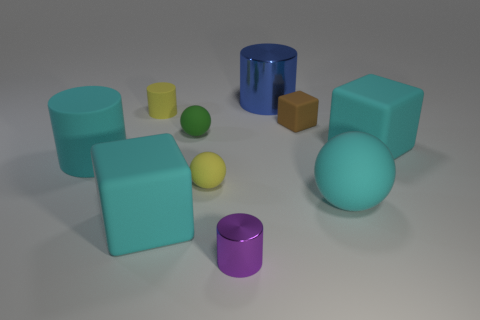There is a ball that is the same color as the small rubber cylinder; what size is it? small 